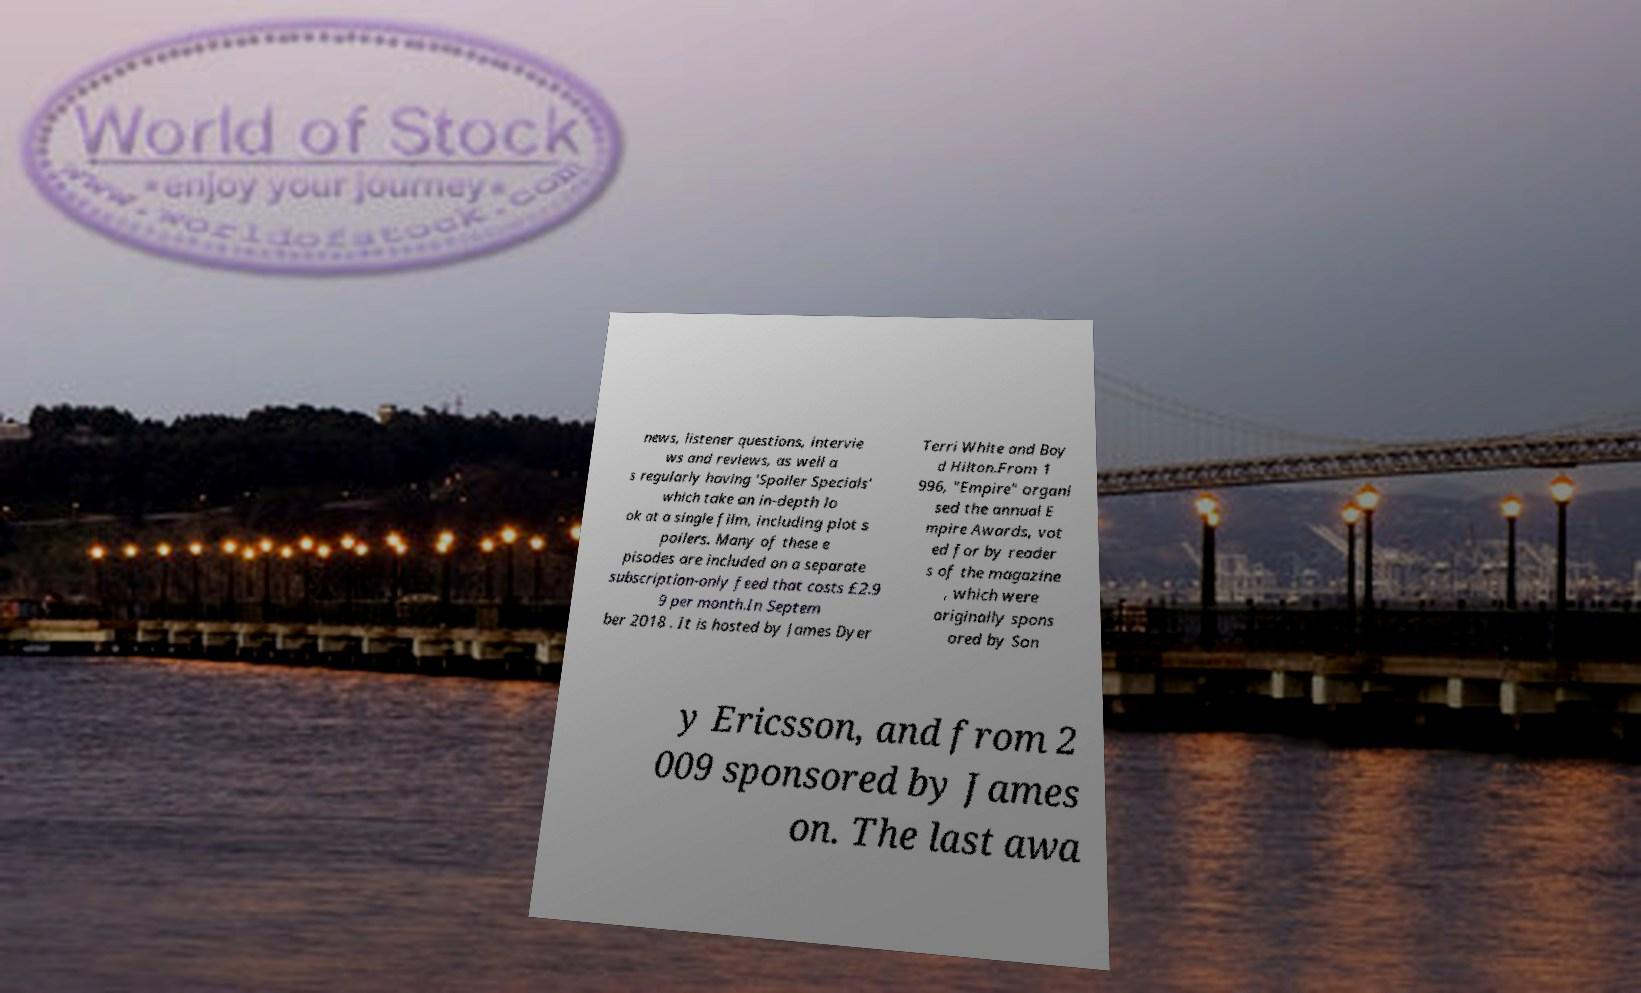There's text embedded in this image that I need extracted. Can you transcribe it verbatim? news, listener questions, intervie ws and reviews, as well a s regularly having 'Spoiler Specials' which take an in-depth lo ok at a single film, including plot s poilers. Many of these e pisodes are included on a separate subscription-only feed that costs £2.9 9 per month.In Septem ber 2018 . It is hosted by James Dyer Terri White and Boy d Hilton.From 1 996, "Empire" organi sed the annual E mpire Awards, vot ed for by reader s of the magazine , which were originally spons ored by Son y Ericsson, and from 2 009 sponsored by James on. The last awa 